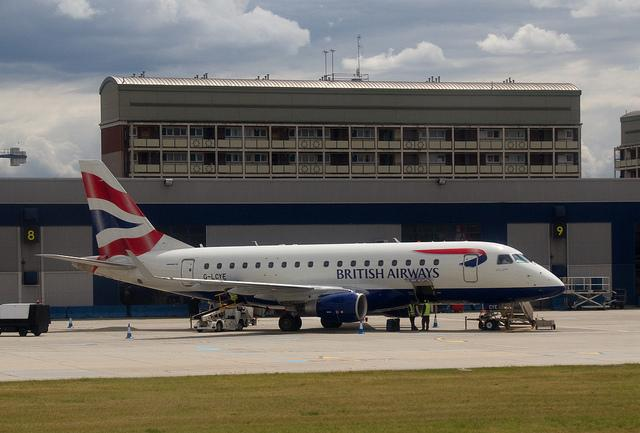What actress was born in the country where the plane comes from? kate winslet 